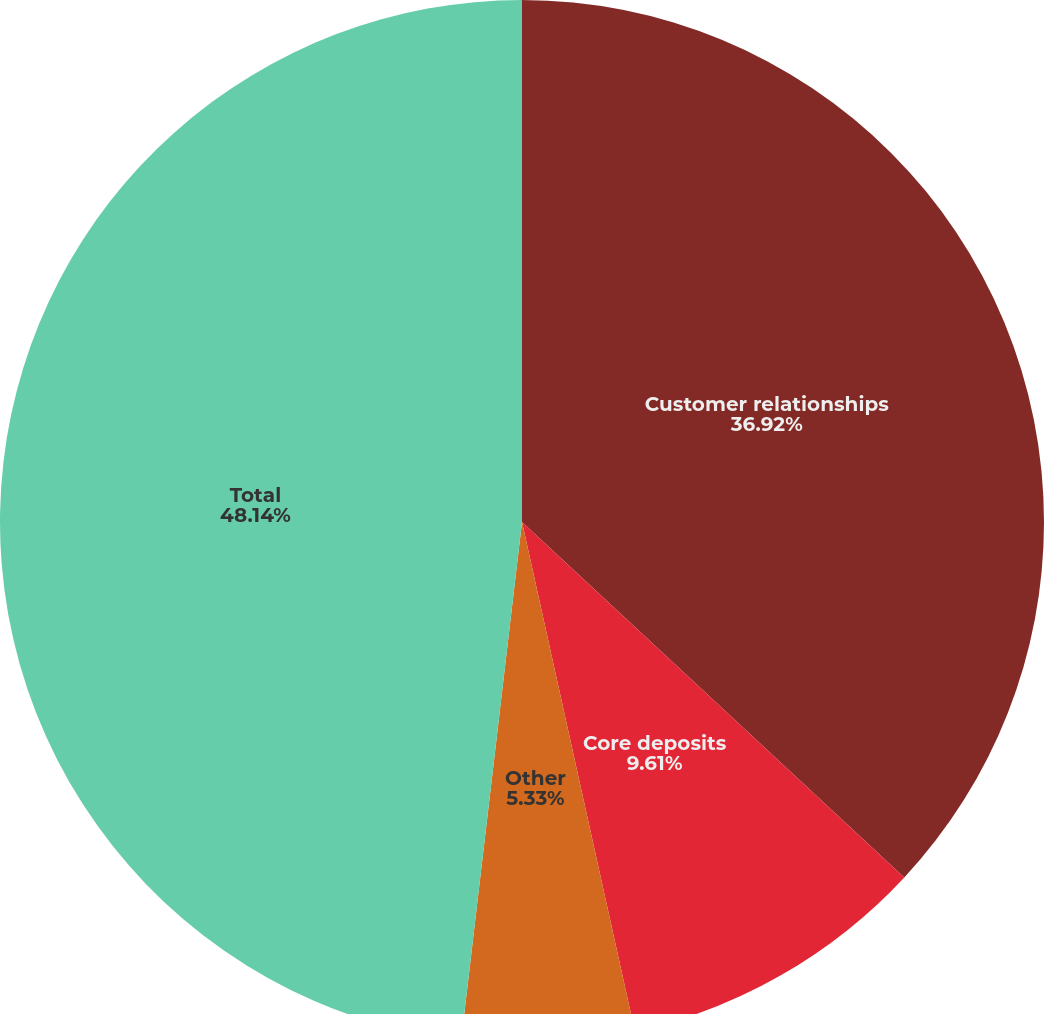Convert chart. <chart><loc_0><loc_0><loc_500><loc_500><pie_chart><fcel>Customer relationships<fcel>Core deposits<fcel>Other<fcel>Total<nl><fcel>36.92%<fcel>9.61%<fcel>5.33%<fcel>48.14%<nl></chart> 